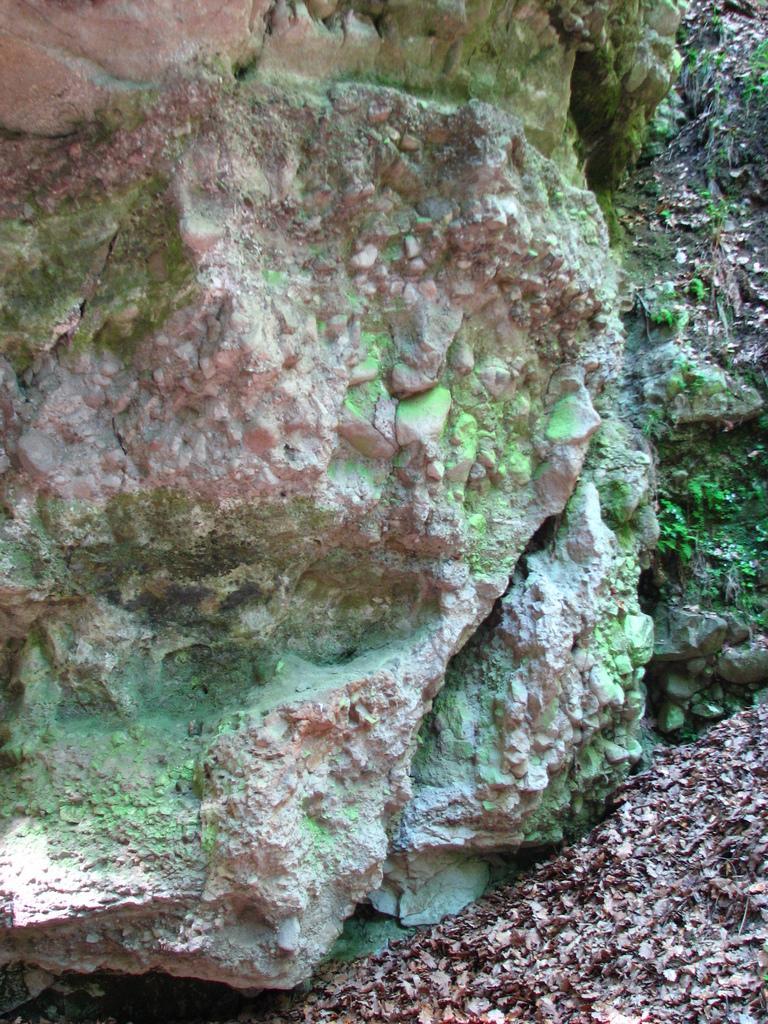Could you give a brief overview of what you see in this image? In this image we can see rocks, leaves, also we can see the grass. 